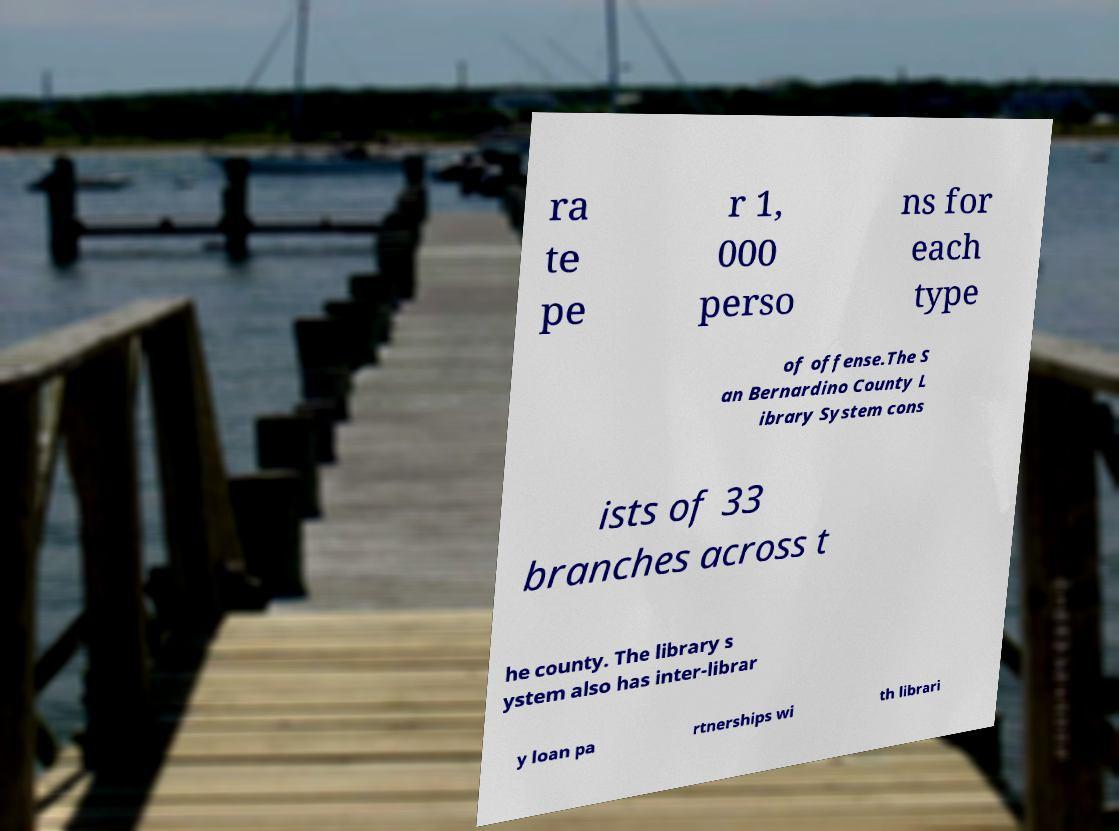What messages or text are displayed in this image? I need them in a readable, typed format. ra te pe r 1, 000 perso ns for each type of offense.The S an Bernardino County L ibrary System cons ists of 33 branches across t he county. The library s ystem also has inter-librar y loan pa rtnerships wi th librari 